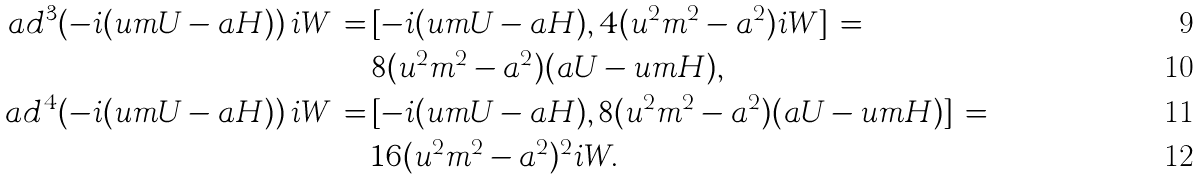Convert formula to latex. <formula><loc_0><loc_0><loc_500><loc_500>\ a d ^ { 3 } ( - i ( u m U - a H ) ) \, i W \, = & \, [ - i ( u m U - a H ) , 4 ( u ^ { 2 } m ^ { 2 } - a ^ { 2 } ) i W ] \, = \\ & \, 8 ( u ^ { 2 } m ^ { 2 } - a ^ { 2 } ) ( a U - u m H ) , \\ \ a d ^ { 4 } ( - i ( u m U - a H ) ) \, i W \, = & \, [ - i ( u m U - a H ) , 8 ( u ^ { 2 } m ^ { 2 } - a ^ { 2 } ) ( a U - u m H ) ] \, = \\ & \, 1 6 ( u ^ { 2 } m ^ { 2 } - a ^ { 2 } ) ^ { 2 } i W .</formula> 